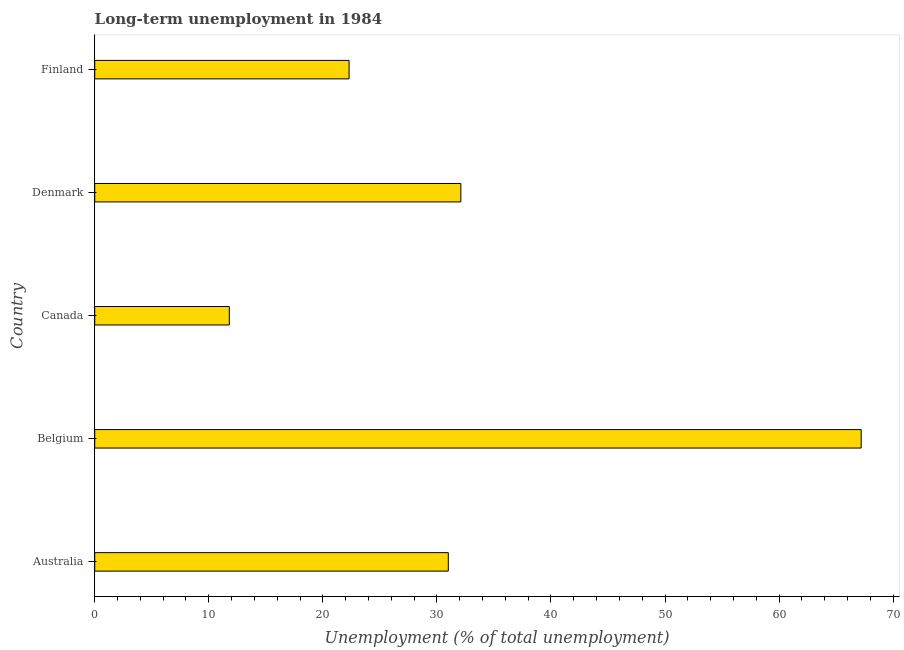Does the graph contain any zero values?
Your answer should be very brief. No. What is the title of the graph?
Offer a very short reply. Long-term unemployment in 1984. What is the label or title of the X-axis?
Provide a short and direct response. Unemployment (% of total unemployment). What is the label or title of the Y-axis?
Your answer should be compact. Country. What is the long-term unemployment in Finland?
Provide a succinct answer. 22.3. Across all countries, what is the maximum long-term unemployment?
Offer a terse response. 67.2. Across all countries, what is the minimum long-term unemployment?
Your answer should be compact. 11.8. In which country was the long-term unemployment minimum?
Your response must be concise. Canada. What is the sum of the long-term unemployment?
Your answer should be compact. 164.4. What is the difference between the long-term unemployment in Canada and Finland?
Your answer should be very brief. -10.5. What is the average long-term unemployment per country?
Give a very brief answer. 32.88. What is the median long-term unemployment?
Provide a succinct answer. 31. What is the ratio of the long-term unemployment in Canada to that in Denmark?
Keep it short and to the point. 0.37. Is the difference between the long-term unemployment in Australia and Belgium greater than the difference between any two countries?
Your answer should be very brief. No. What is the difference between the highest and the second highest long-term unemployment?
Offer a very short reply. 35.1. Is the sum of the long-term unemployment in Belgium and Finland greater than the maximum long-term unemployment across all countries?
Offer a very short reply. Yes. What is the difference between the highest and the lowest long-term unemployment?
Your response must be concise. 55.4. In how many countries, is the long-term unemployment greater than the average long-term unemployment taken over all countries?
Your response must be concise. 1. How many countries are there in the graph?
Your answer should be very brief. 5. What is the difference between two consecutive major ticks on the X-axis?
Your response must be concise. 10. What is the Unemployment (% of total unemployment) of Australia?
Offer a very short reply. 31. What is the Unemployment (% of total unemployment) in Belgium?
Your answer should be compact. 67.2. What is the Unemployment (% of total unemployment) in Canada?
Your answer should be compact. 11.8. What is the Unemployment (% of total unemployment) in Denmark?
Ensure brevity in your answer.  32.1. What is the Unemployment (% of total unemployment) in Finland?
Your answer should be very brief. 22.3. What is the difference between the Unemployment (% of total unemployment) in Australia and Belgium?
Make the answer very short. -36.2. What is the difference between the Unemployment (% of total unemployment) in Belgium and Canada?
Ensure brevity in your answer.  55.4. What is the difference between the Unemployment (% of total unemployment) in Belgium and Denmark?
Your answer should be compact. 35.1. What is the difference between the Unemployment (% of total unemployment) in Belgium and Finland?
Offer a terse response. 44.9. What is the difference between the Unemployment (% of total unemployment) in Canada and Denmark?
Your answer should be compact. -20.3. What is the difference between the Unemployment (% of total unemployment) in Canada and Finland?
Offer a terse response. -10.5. What is the difference between the Unemployment (% of total unemployment) in Denmark and Finland?
Your answer should be very brief. 9.8. What is the ratio of the Unemployment (% of total unemployment) in Australia to that in Belgium?
Make the answer very short. 0.46. What is the ratio of the Unemployment (% of total unemployment) in Australia to that in Canada?
Your answer should be compact. 2.63. What is the ratio of the Unemployment (% of total unemployment) in Australia to that in Finland?
Provide a succinct answer. 1.39. What is the ratio of the Unemployment (% of total unemployment) in Belgium to that in Canada?
Your response must be concise. 5.7. What is the ratio of the Unemployment (% of total unemployment) in Belgium to that in Denmark?
Provide a short and direct response. 2.09. What is the ratio of the Unemployment (% of total unemployment) in Belgium to that in Finland?
Offer a terse response. 3.01. What is the ratio of the Unemployment (% of total unemployment) in Canada to that in Denmark?
Keep it short and to the point. 0.37. What is the ratio of the Unemployment (% of total unemployment) in Canada to that in Finland?
Provide a succinct answer. 0.53. What is the ratio of the Unemployment (% of total unemployment) in Denmark to that in Finland?
Offer a terse response. 1.44. 